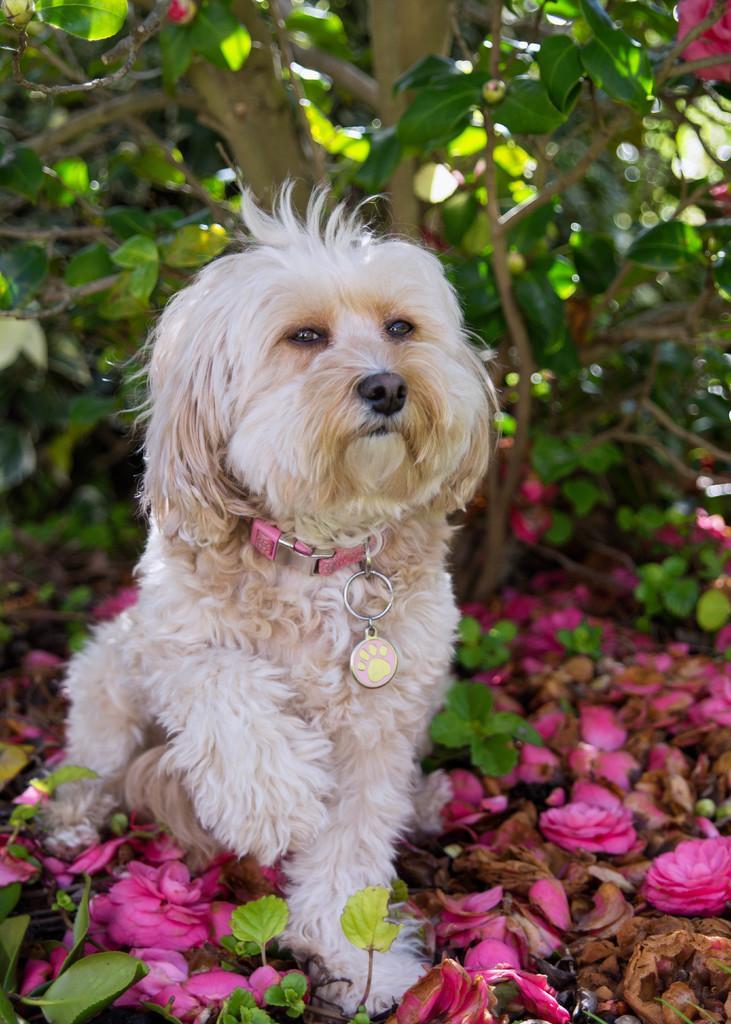In one or two sentences, can you explain what this image depicts? In the foreground of the picture there are flowers, dry leaves, leaves and a dog. In the background there is a tree. 